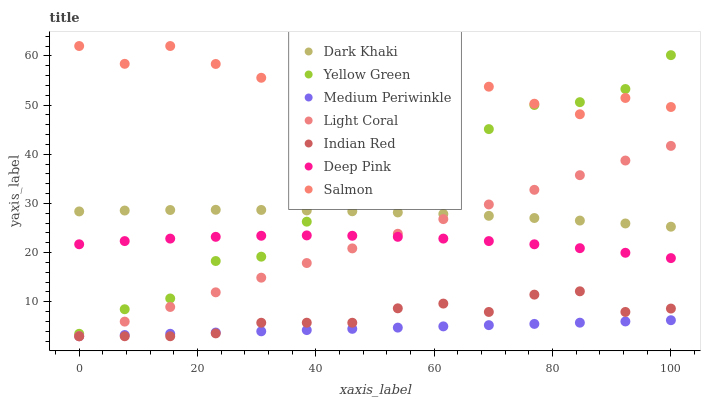Does Medium Periwinkle have the minimum area under the curve?
Answer yes or no. Yes. Does Salmon have the maximum area under the curve?
Answer yes or no. Yes. Does Deep Pink have the minimum area under the curve?
Answer yes or no. No. Does Deep Pink have the maximum area under the curve?
Answer yes or no. No. Is Medium Periwinkle the smoothest?
Answer yes or no. Yes. Is Salmon the roughest?
Answer yes or no. Yes. Is Deep Pink the smoothest?
Answer yes or no. No. Is Deep Pink the roughest?
Answer yes or no. No. Does Light Coral have the lowest value?
Answer yes or no. Yes. Does Deep Pink have the lowest value?
Answer yes or no. No. Does Salmon have the highest value?
Answer yes or no. Yes. Does Deep Pink have the highest value?
Answer yes or no. No. Is Medium Periwinkle less than Dark Khaki?
Answer yes or no. Yes. Is Salmon greater than Indian Red?
Answer yes or no. Yes. Does Dark Khaki intersect Light Coral?
Answer yes or no. Yes. Is Dark Khaki less than Light Coral?
Answer yes or no. No. Is Dark Khaki greater than Light Coral?
Answer yes or no. No. Does Medium Periwinkle intersect Dark Khaki?
Answer yes or no. No. 